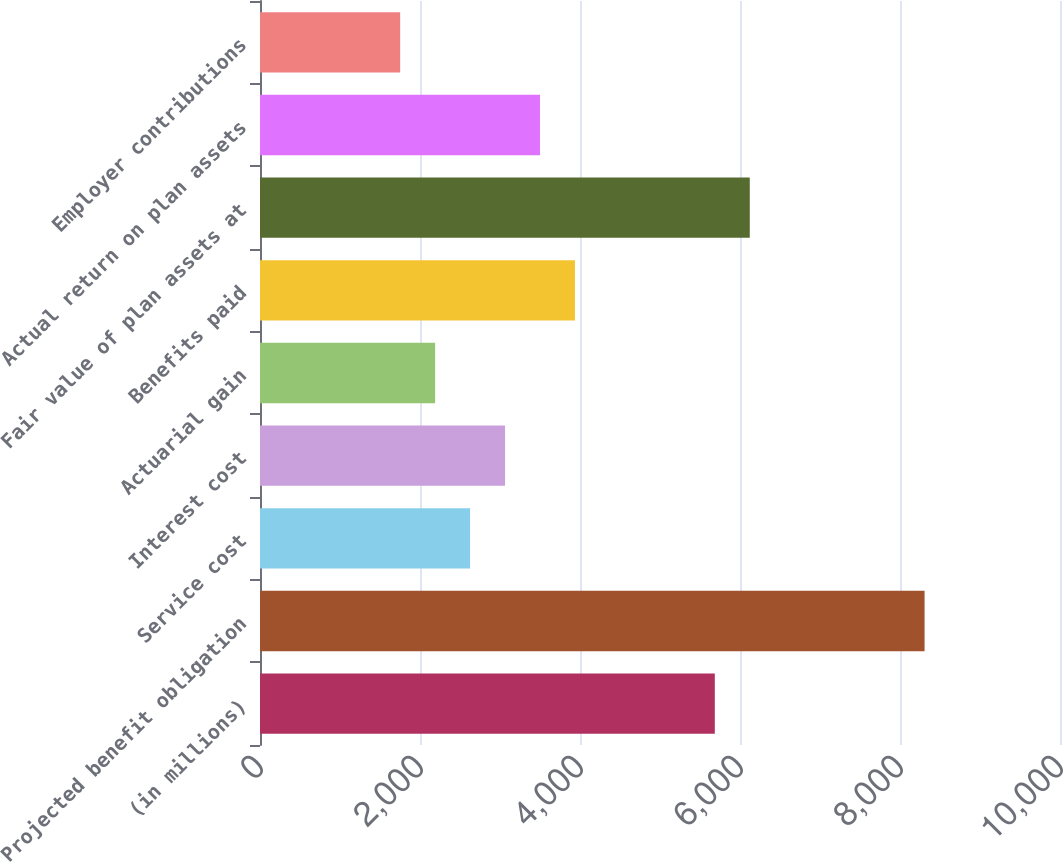Convert chart to OTSL. <chart><loc_0><loc_0><loc_500><loc_500><bar_chart><fcel>(in millions)<fcel>Projected benefit obligation<fcel>Service cost<fcel>Interest cost<fcel>Actuarial gain<fcel>Benefits paid<fcel>Fair value of plan assets at<fcel>Actual return on plan assets<fcel>Employer contributions<nl><fcel>5685.07<fcel>8307.13<fcel>2626<fcel>3063.01<fcel>2188.99<fcel>3937.03<fcel>6122.08<fcel>3500.02<fcel>1751.98<nl></chart> 